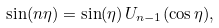Convert formula to latex. <formula><loc_0><loc_0><loc_500><loc_500>\sin ( n \eta ) = \sin ( \eta ) \, U _ { n - 1 } ( \cos \eta ) ,</formula> 